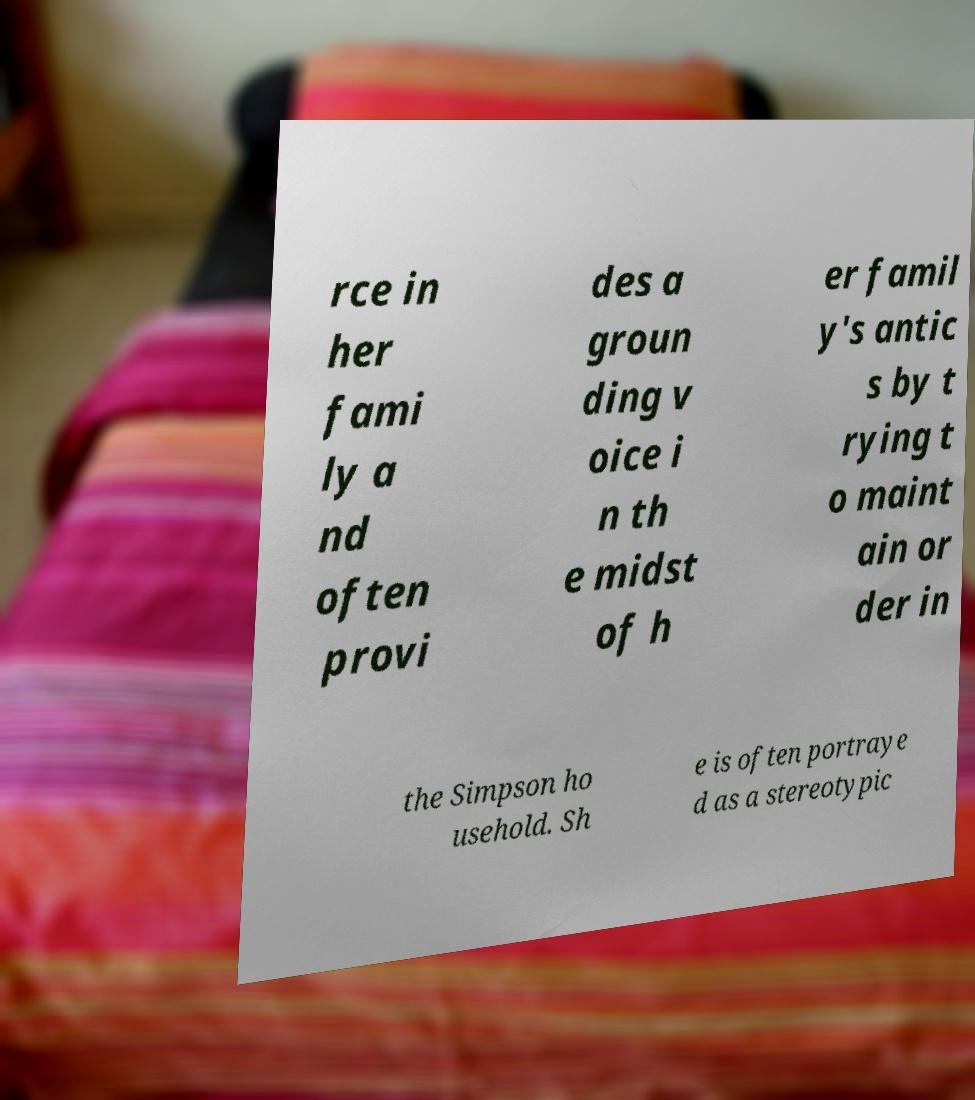Please read and relay the text visible in this image. What does it say? rce in her fami ly a nd often provi des a groun ding v oice i n th e midst of h er famil y's antic s by t rying t o maint ain or der in the Simpson ho usehold. Sh e is often portraye d as a stereotypic 